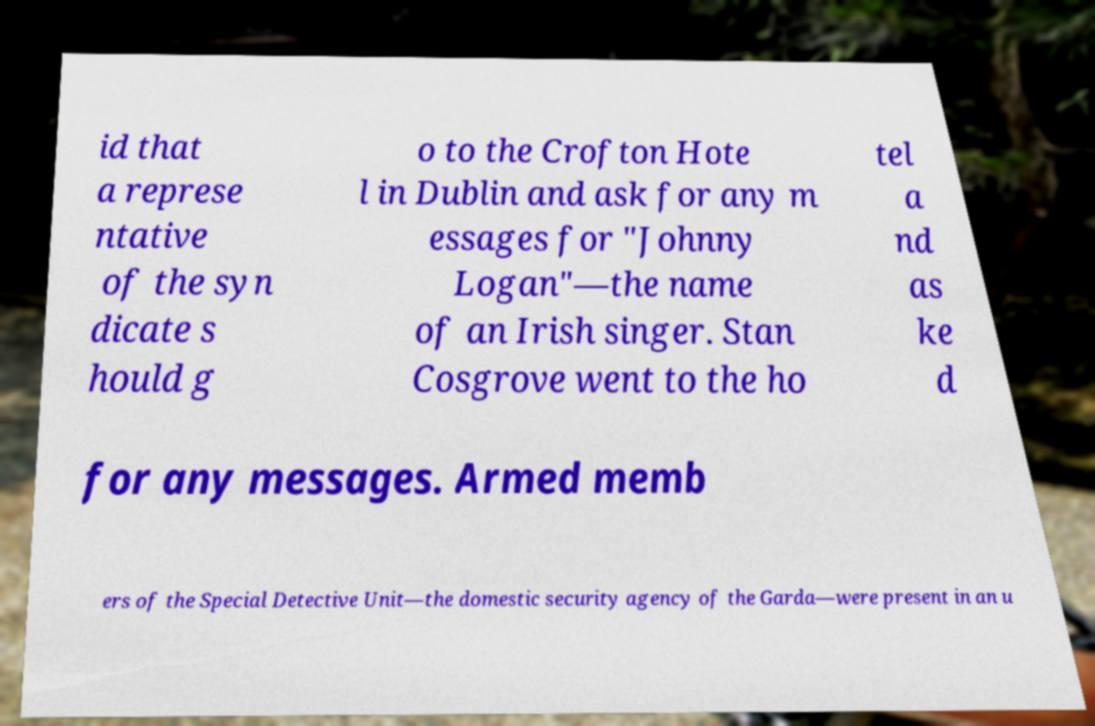For documentation purposes, I need the text within this image transcribed. Could you provide that? id that a represe ntative of the syn dicate s hould g o to the Crofton Hote l in Dublin and ask for any m essages for "Johnny Logan"—the name of an Irish singer. Stan Cosgrove went to the ho tel a nd as ke d for any messages. Armed memb ers of the Special Detective Unit—the domestic security agency of the Garda—were present in an u 